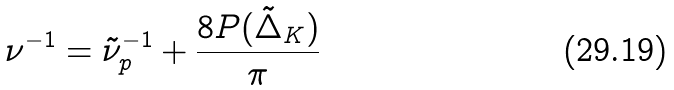<formula> <loc_0><loc_0><loc_500><loc_500>\nu ^ { - 1 } = \tilde { \nu } ^ { - 1 } _ { p } + \frac { 8 P ( \tilde { \Delta } _ { K } ) } { \pi }</formula> 